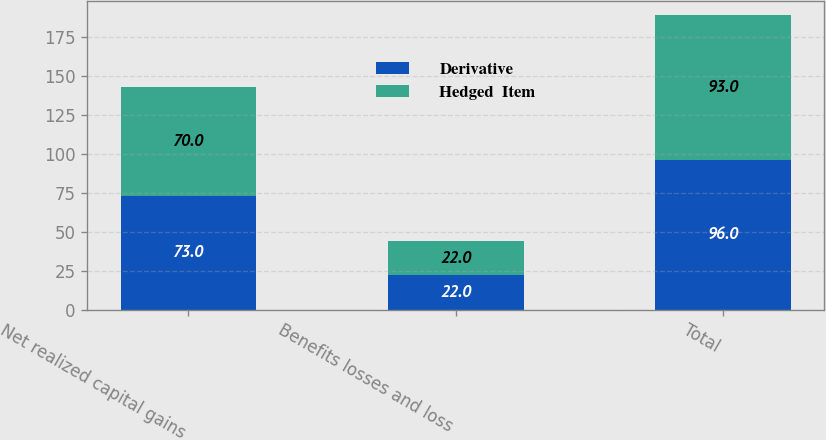<chart> <loc_0><loc_0><loc_500><loc_500><stacked_bar_chart><ecel><fcel>Net realized capital gains<fcel>Benefits losses and loss<fcel>Total<nl><fcel>Derivative<fcel>73<fcel>22<fcel>96<nl><fcel>Hedged  Item<fcel>70<fcel>22<fcel>93<nl></chart> 